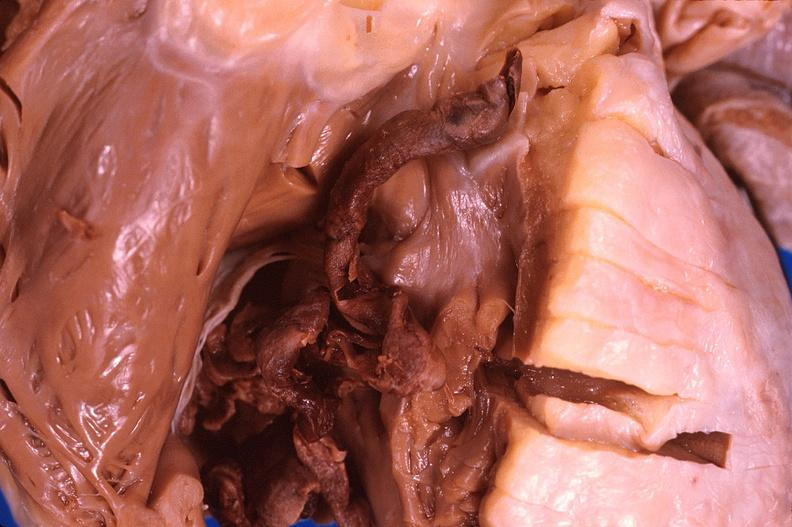does this image show thromboembolus from leg veins in right ventricle?
Answer the question using a single word or phrase. Yes 